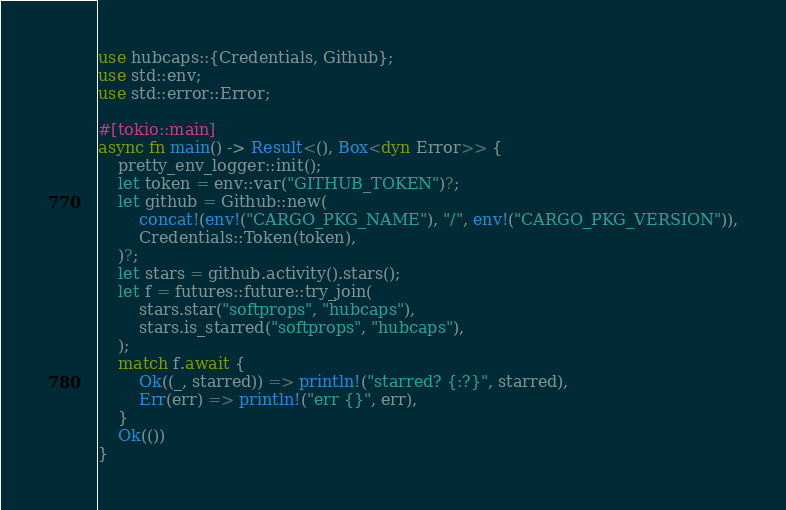<code> <loc_0><loc_0><loc_500><loc_500><_Rust_>use hubcaps::{Credentials, Github};
use std::env;
use std::error::Error;

#[tokio::main]
async fn main() -> Result<(), Box<dyn Error>> {
    pretty_env_logger::init();
    let token = env::var("GITHUB_TOKEN")?;
    let github = Github::new(
        concat!(env!("CARGO_PKG_NAME"), "/", env!("CARGO_PKG_VERSION")),
        Credentials::Token(token),
    )?;
    let stars = github.activity().stars();
    let f = futures::future::try_join(
        stars.star("softprops", "hubcaps"),
        stars.is_starred("softprops", "hubcaps"),
    );
    match f.await {
        Ok((_, starred)) => println!("starred? {:?}", starred),
        Err(err) => println!("err {}", err),
    }
    Ok(())
}
</code> 